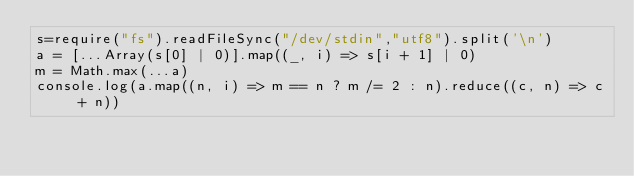Convert code to text. <code><loc_0><loc_0><loc_500><loc_500><_JavaScript_>s=require("fs").readFileSync("/dev/stdin","utf8").split('\n')
a = [...Array(s[0] | 0)].map((_, i) => s[i + 1] | 0)
m = Math.max(...a)
console.log(a.map((n, i) => m == n ? m /= 2 : n).reduce((c, n) => c + n))
</code> 